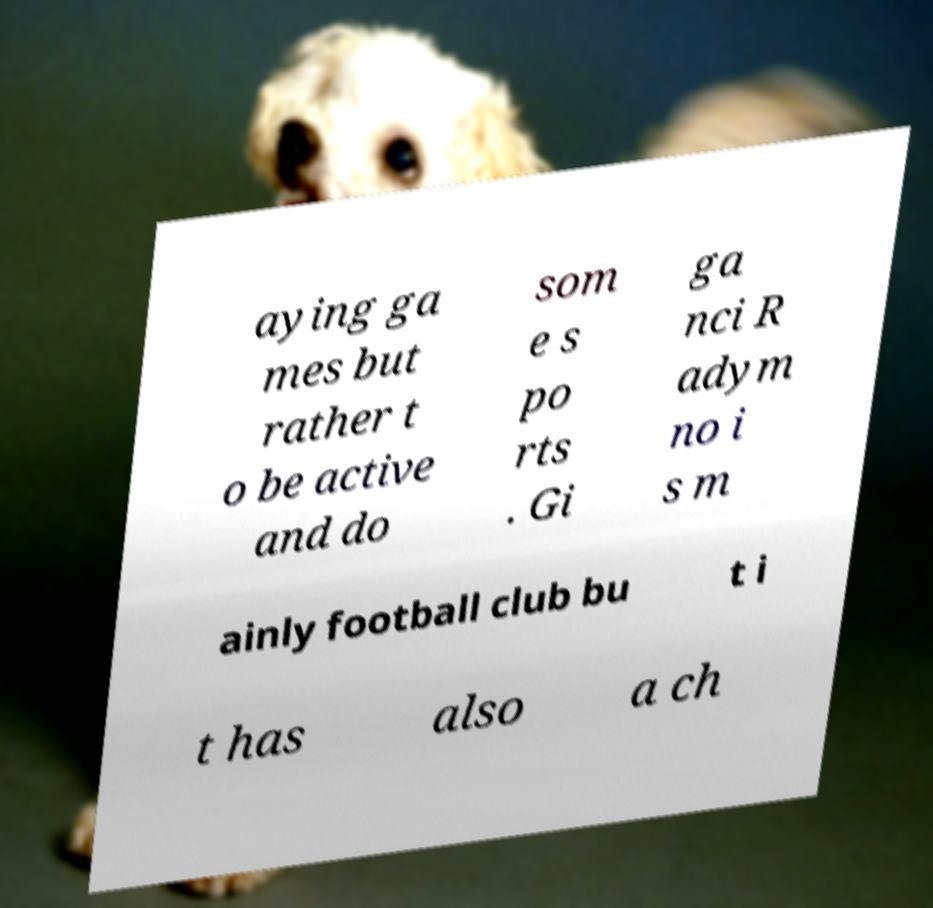Could you assist in decoding the text presented in this image and type it out clearly? aying ga mes but rather t o be active and do som e s po rts . Gi ga nci R adym no i s m ainly football club bu t i t has also a ch 